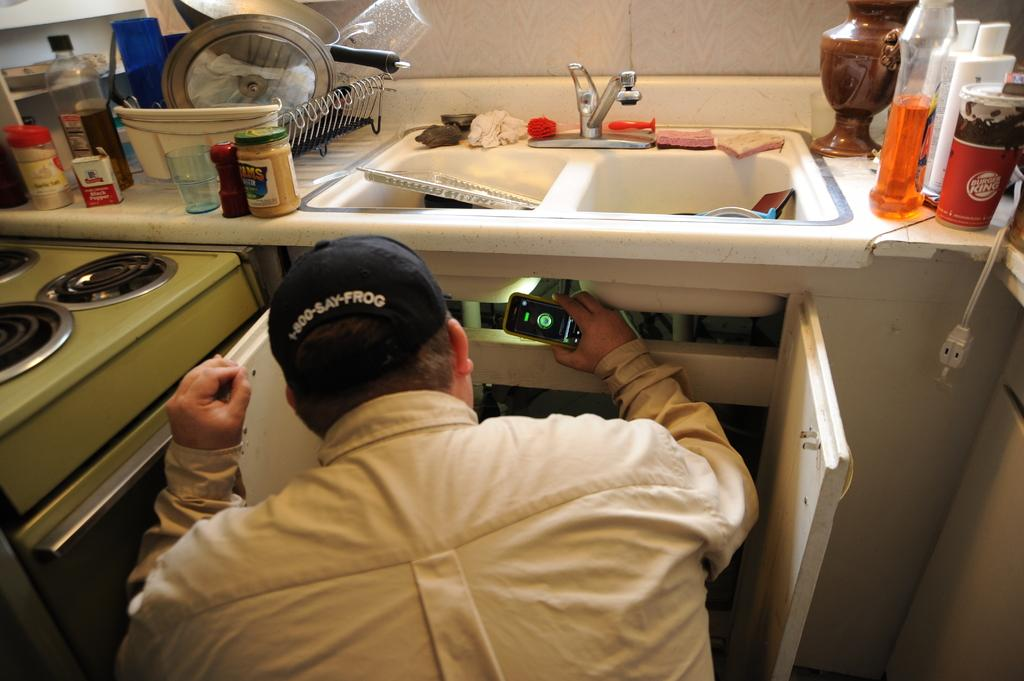<image>
Relay a brief, clear account of the picture shown. A worker peers under a sink while wearing a cap with 1-800-SAY-FROG on it. 